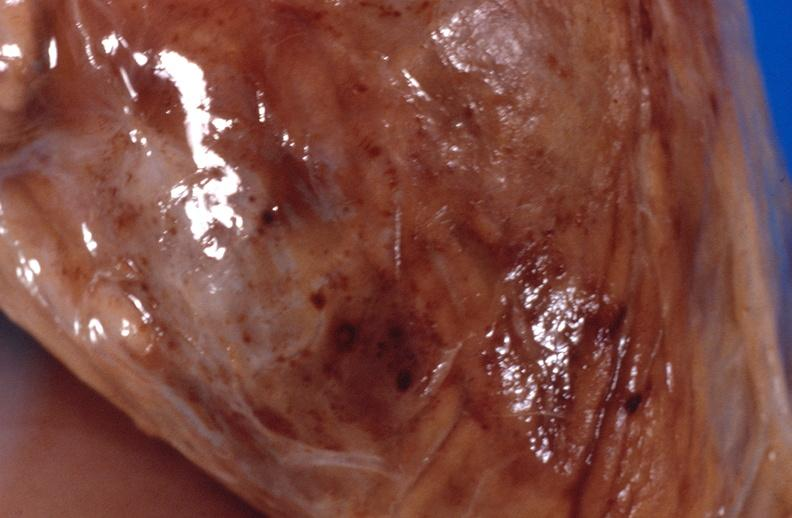what is present?
Answer the question using a single word or phrase. Muscle 